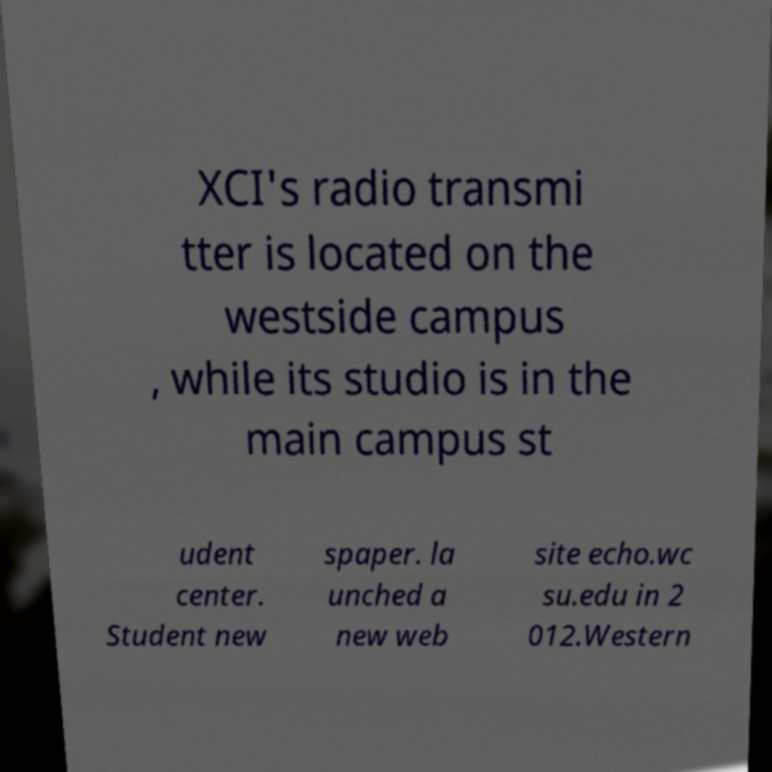What messages or text are displayed in this image? I need them in a readable, typed format. XCI's radio transmi tter is located on the westside campus , while its studio is in the main campus st udent center. Student new spaper. la unched a new web site echo.wc su.edu in 2 012.Western 